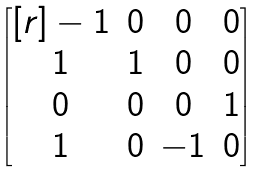<formula> <loc_0><loc_0><loc_500><loc_500>\begin{bmatrix} [ r ] - 1 & 0 & 0 & 0 \\ 1 & 1 & 0 & 0 \\ 0 & 0 & 0 & 1 \\ 1 & 0 & - 1 & 0 \\ \end{bmatrix}</formula> 